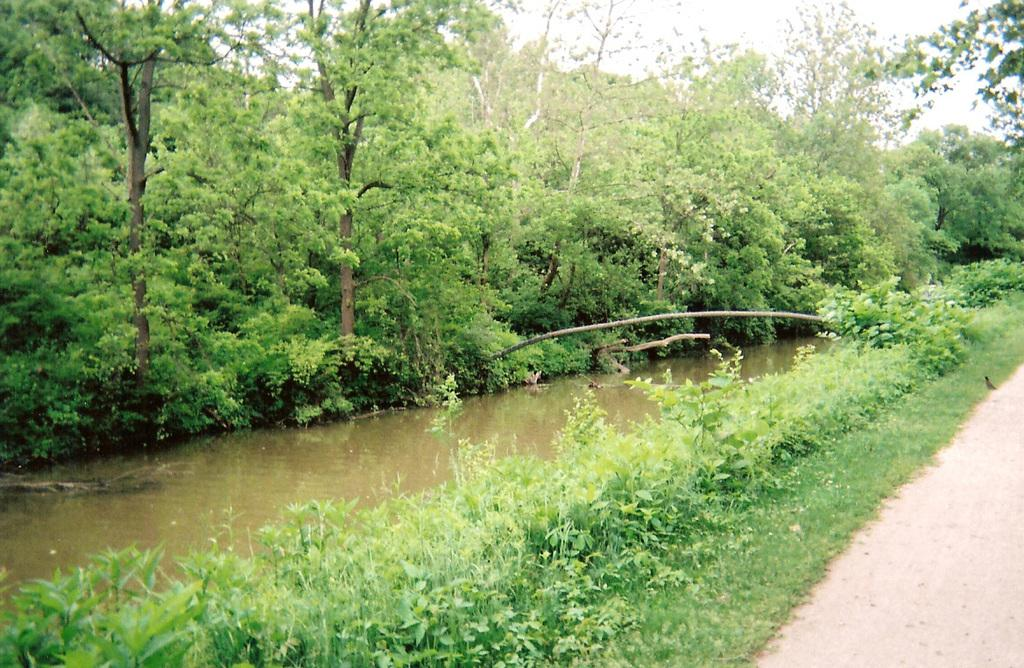What type of vegetation can be seen in the image? There are trees and plants in the image. What natural element is visible in the image? There is water visible in the image. How would you describe the sky in the image? The sky is cloudy in the image. How many pets are visible in the image? There are no pets present in the image. What type of haircut does the tree on the left have? Trees do not have haircuts, as they are plants and not humans or animals. 